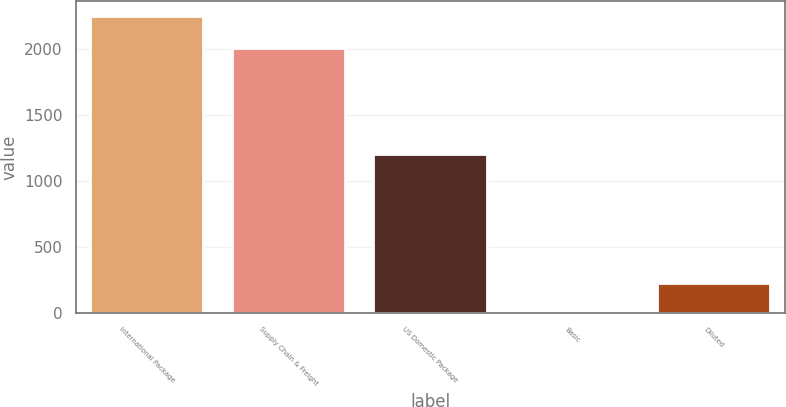Convert chart. <chart><loc_0><loc_0><loc_500><loc_500><bar_chart><fcel>International Package<fcel>Supply Chain & Freight<fcel>US Domestic Package<fcel>Basic<fcel>Diluted<nl><fcel>2251<fcel>2009<fcel>1208<fcel>0.96<fcel>225.96<nl></chart> 